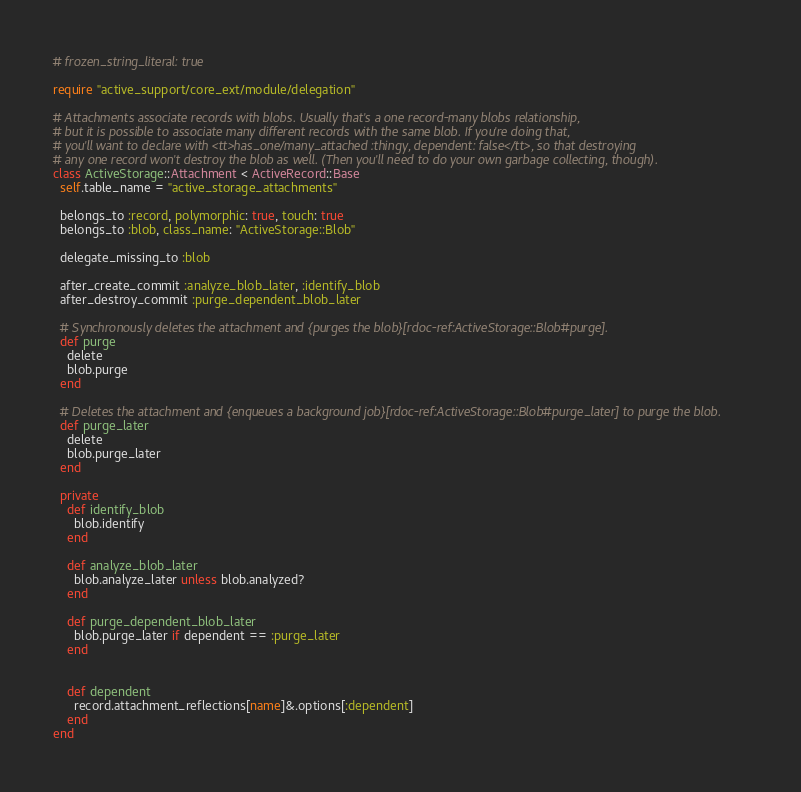<code> <loc_0><loc_0><loc_500><loc_500><_Ruby_># frozen_string_literal: true

require "active_support/core_ext/module/delegation"

# Attachments associate records with blobs. Usually that's a one record-many blobs relationship,
# but it is possible to associate many different records with the same blob. If you're doing that,
# you'll want to declare with <tt>has_one/many_attached :thingy, dependent: false</tt>, so that destroying
# any one record won't destroy the blob as well. (Then you'll need to do your own garbage collecting, though).
class ActiveStorage::Attachment < ActiveRecord::Base
  self.table_name = "active_storage_attachments"

  belongs_to :record, polymorphic: true, touch: true
  belongs_to :blob, class_name: "ActiveStorage::Blob"

  delegate_missing_to :blob

  after_create_commit :analyze_blob_later, :identify_blob
  after_destroy_commit :purge_dependent_blob_later

  # Synchronously deletes the attachment and {purges the blob}[rdoc-ref:ActiveStorage::Blob#purge].
  def purge
    delete
    blob.purge
  end

  # Deletes the attachment and {enqueues a background job}[rdoc-ref:ActiveStorage::Blob#purge_later] to purge the blob.
  def purge_later
    delete
    blob.purge_later
  end

  private
    def identify_blob
      blob.identify
    end

    def analyze_blob_later
      blob.analyze_later unless blob.analyzed?
    end

    def purge_dependent_blob_later
      blob.purge_later if dependent == :purge_later
    end


    def dependent
      record.attachment_reflections[name]&.options[:dependent]
    end
end
</code> 